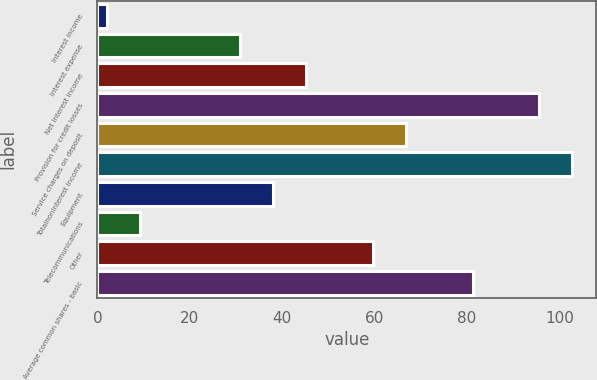Convert chart. <chart><loc_0><loc_0><loc_500><loc_500><bar_chart><fcel>Interest income<fcel>Interest expense<fcel>Net interest income<fcel>Provision for credit losses<fcel>Service charges on deposit<fcel>Totalnoninterest income<fcel>Equipment<fcel>Telecommunications<fcel>Other<fcel>Average common shares - basic<nl><fcel>2<fcel>30.8<fcel>45.2<fcel>95.6<fcel>66.8<fcel>102.8<fcel>38<fcel>9.2<fcel>59.6<fcel>81.2<nl></chart> 